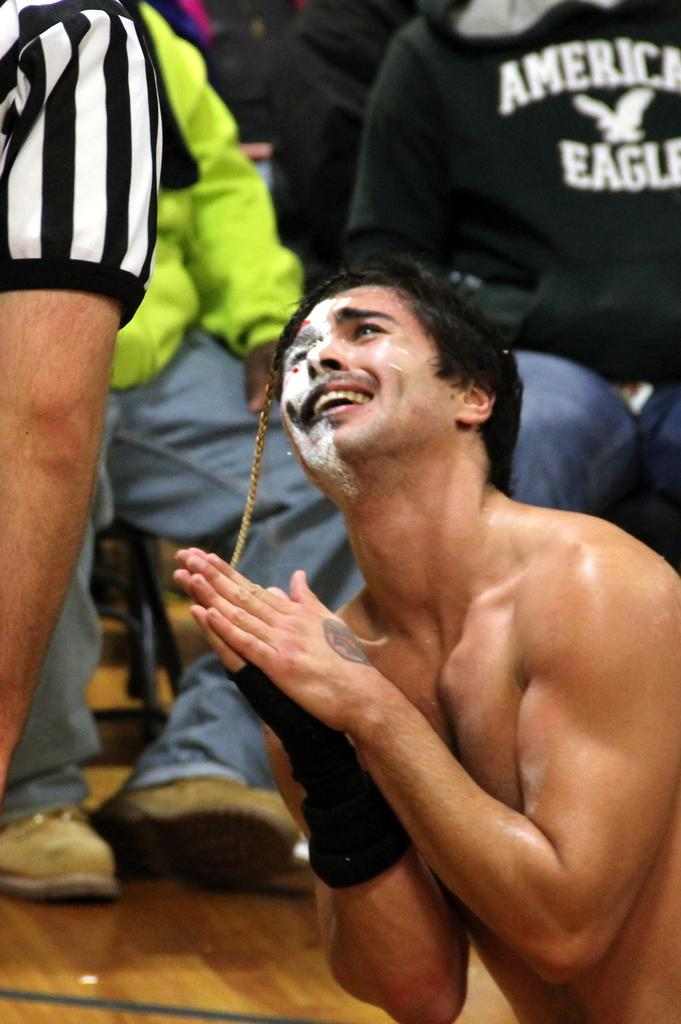<image>
Give a short and clear explanation of the subsequent image. A man pleading with a ref in front of someone wearing an American Eagle shirt. 